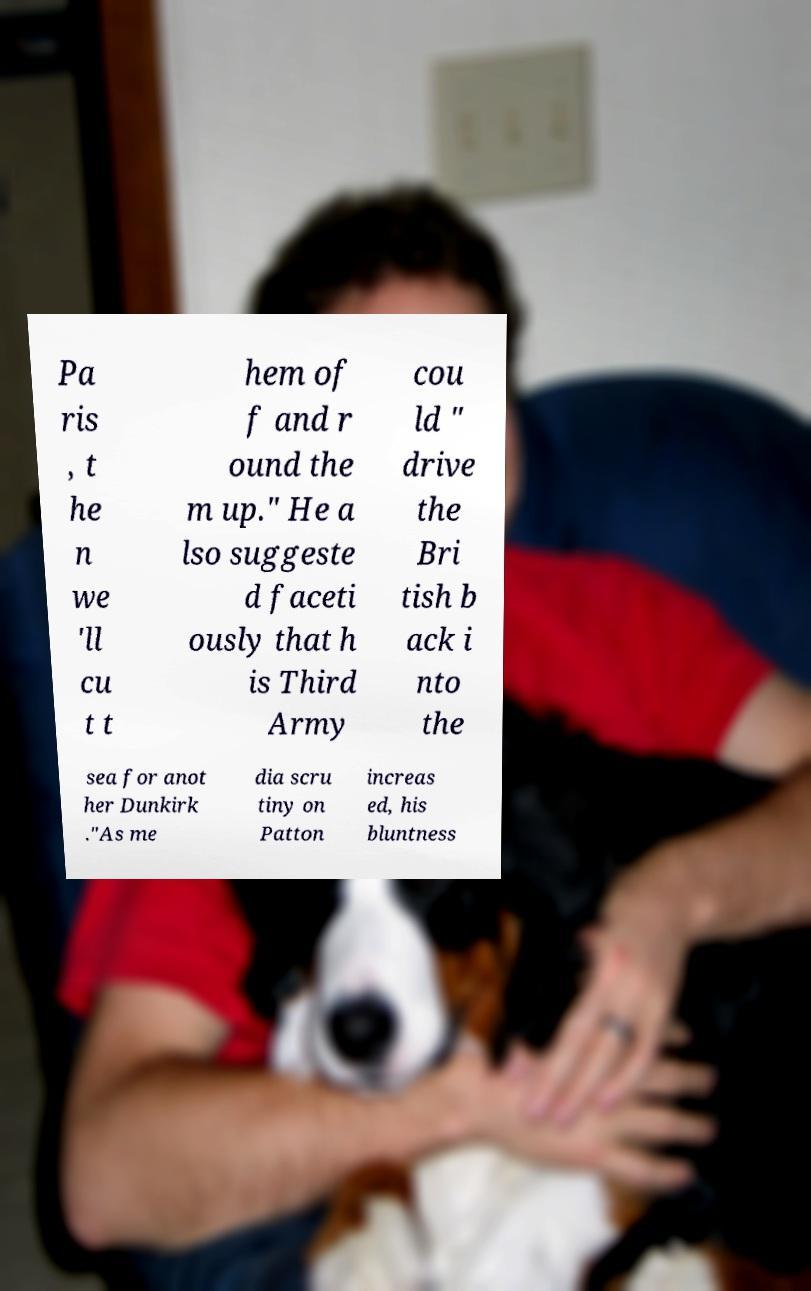For documentation purposes, I need the text within this image transcribed. Could you provide that? Pa ris , t he n we 'll cu t t hem of f and r ound the m up." He a lso suggeste d faceti ously that h is Third Army cou ld " drive the Bri tish b ack i nto the sea for anot her Dunkirk ."As me dia scru tiny on Patton increas ed, his bluntness 